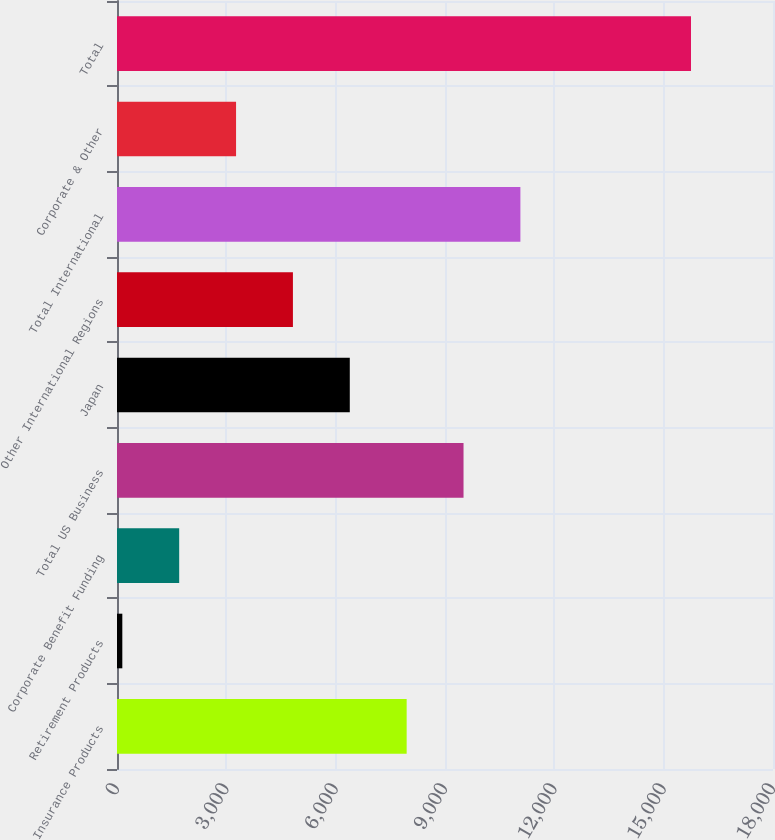<chart> <loc_0><loc_0><loc_500><loc_500><bar_chart><fcel>Insurance Products<fcel>Retirement Products<fcel>Corporate Benefit Funding<fcel>Total US Business<fcel>Japan<fcel>Other International Regions<fcel>Total International<fcel>Corporate & Other<fcel>Total<nl><fcel>7948<fcel>146<fcel>1706.4<fcel>9508.4<fcel>6387.6<fcel>4827.2<fcel>11068.8<fcel>3266.8<fcel>15750<nl></chart> 